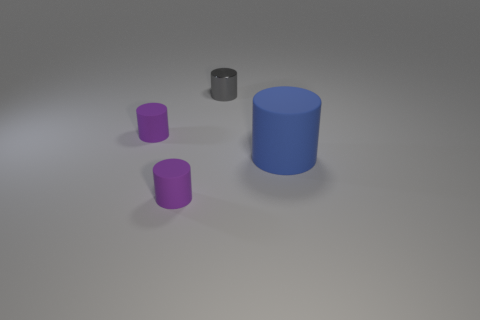There is a blue object that is the same shape as the tiny gray thing; what size is it?
Provide a short and direct response. Large. There is a matte thing right of the tiny metal thing; what is its shape?
Offer a very short reply. Cylinder. Does the large thing have the same shape as the small rubber object behind the large blue rubber cylinder?
Offer a terse response. Yes. Are there an equal number of small metal objects that are behind the big blue cylinder and big blue rubber cylinders that are on the left side of the small gray cylinder?
Provide a succinct answer. No. Do the cylinder that is in front of the large blue matte object and the tiny matte cylinder that is behind the large matte object have the same color?
Your response must be concise. Yes. Is the number of small things that are in front of the gray cylinder greater than the number of blue things?
Provide a succinct answer. Yes. What is the large blue thing made of?
Your answer should be very brief. Rubber. There is a purple matte thing that is behind the cylinder on the right side of the tiny gray metal object; how big is it?
Ensure brevity in your answer.  Small. There is a metal cylinder that is on the left side of the large rubber cylinder; what color is it?
Provide a succinct answer. Gray. Is there a purple rubber object that has the same shape as the small gray object?
Ensure brevity in your answer.  Yes. 